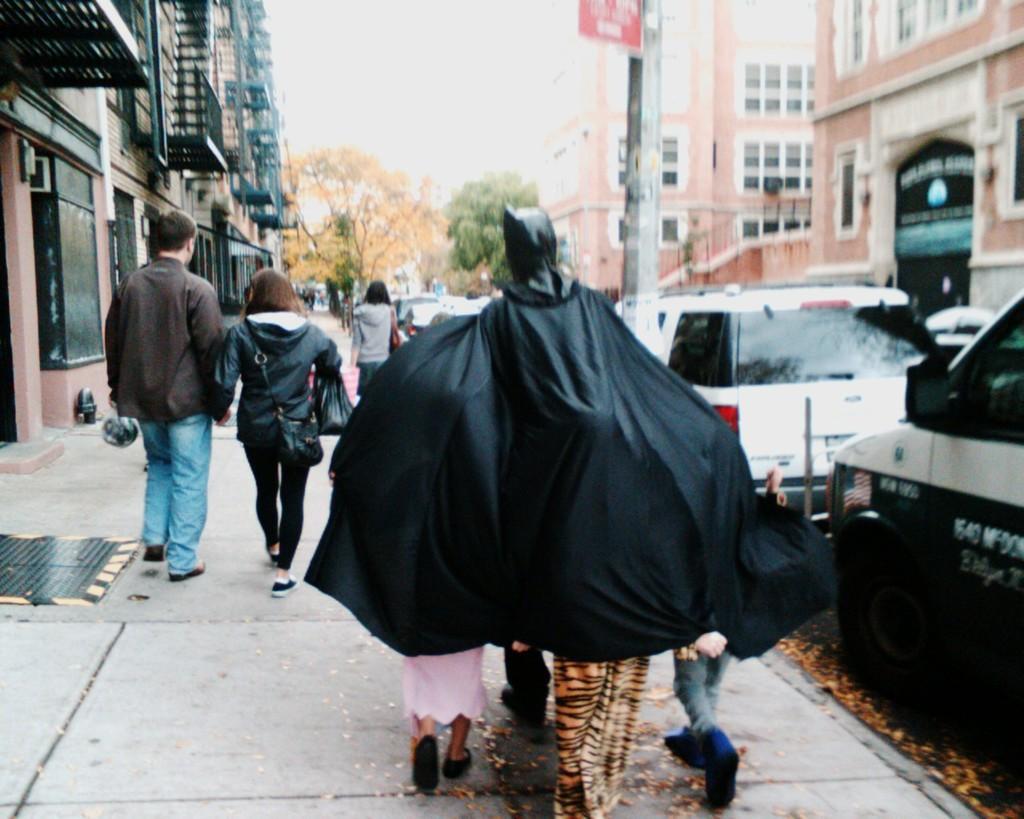Describe this image in one or two sentences. In the center of the image some persons are there. On the right side of the image we can see a buildings, pole, board, cars are present. At the bottom of the image ground is there. At the top of the image sky is present. In the background of the image trees are there. 